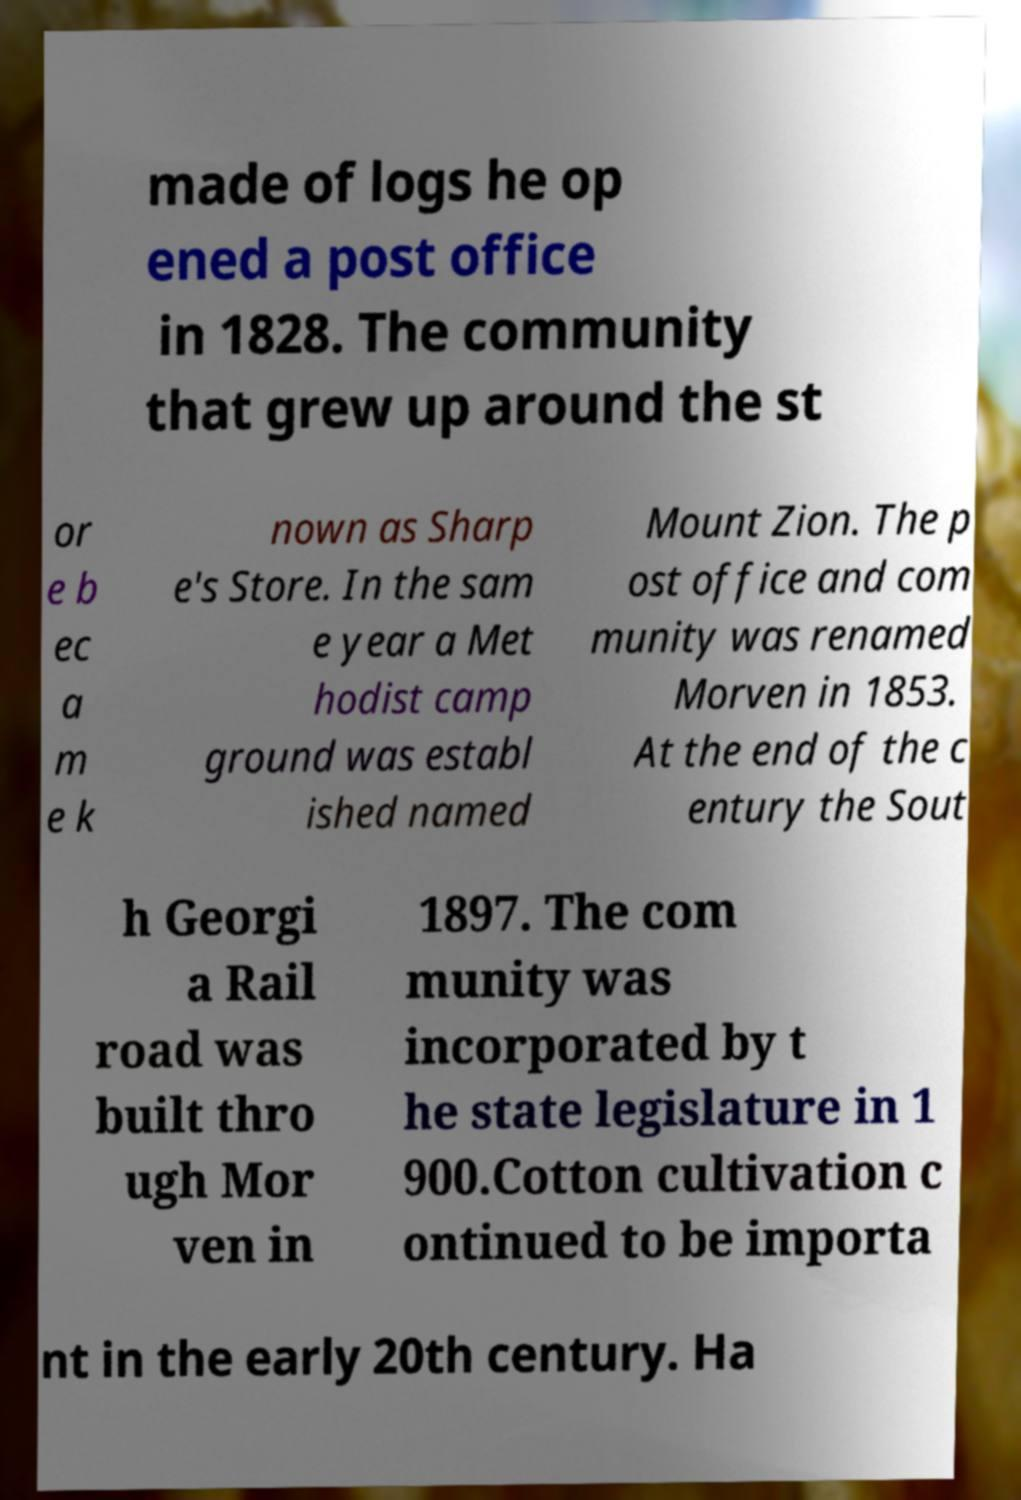Can you read and provide the text displayed in the image?This photo seems to have some interesting text. Can you extract and type it out for me? made of logs he op ened a post office in 1828. The community that grew up around the st or e b ec a m e k nown as Sharp e's Store. In the sam e year a Met hodist camp ground was establ ished named Mount Zion. The p ost office and com munity was renamed Morven in 1853. At the end of the c entury the Sout h Georgi a Rail road was built thro ugh Mor ven in 1897. The com munity was incorporated by t he state legislature in 1 900.Cotton cultivation c ontinued to be importa nt in the early 20th century. Ha 